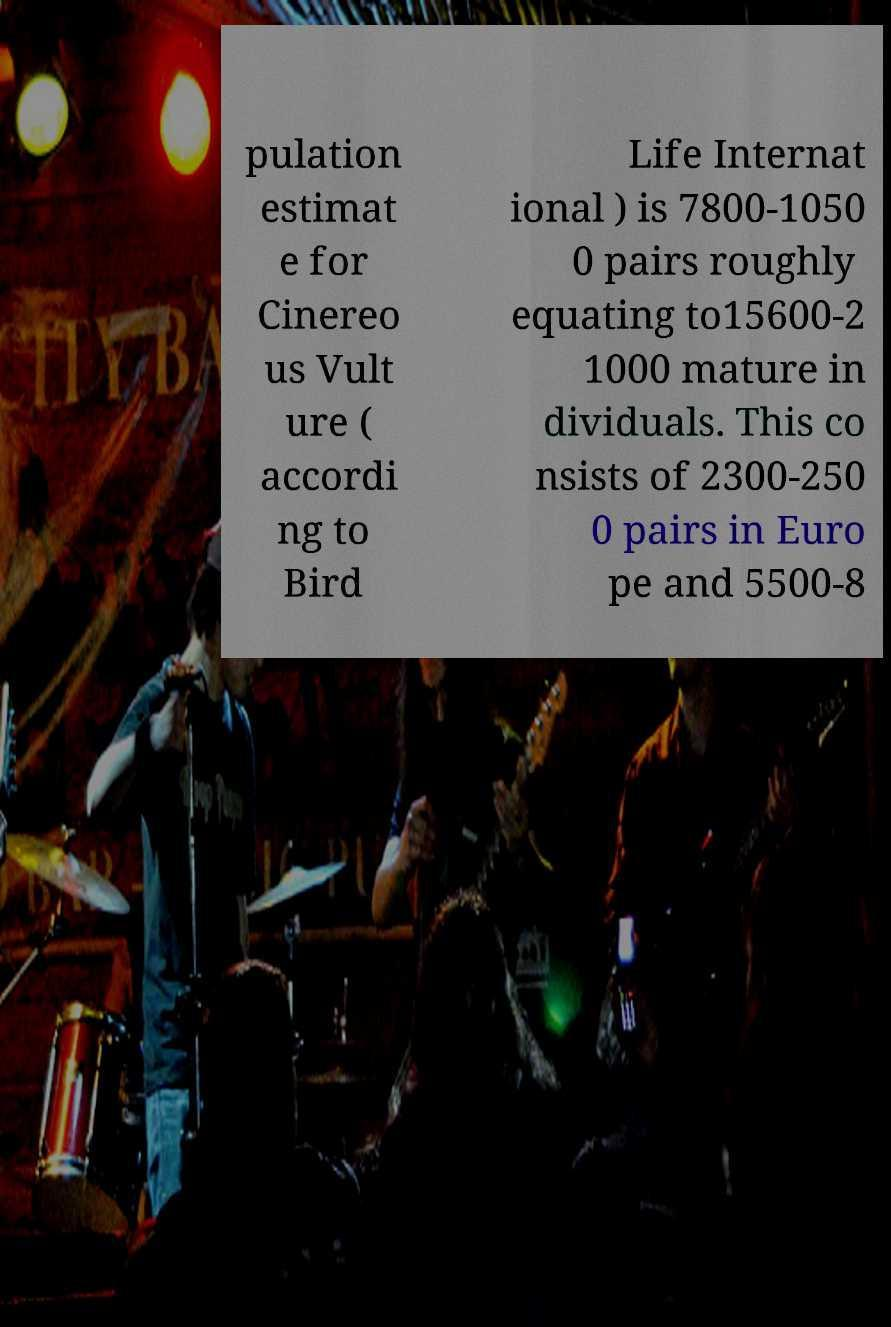There's text embedded in this image that I need extracted. Can you transcribe it verbatim? pulation estimat e for Cinereo us Vult ure ( accordi ng to Bird Life Internat ional ) is 7800-1050 0 pairs roughly equating to15600-2 1000 mature in dividuals. This co nsists of 2300-250 0 pairs in Euro pe and 5500-8 